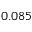<formula> <loc_0><loc_0><loc_500><loc_500>0 . 0 8 5</formula> 